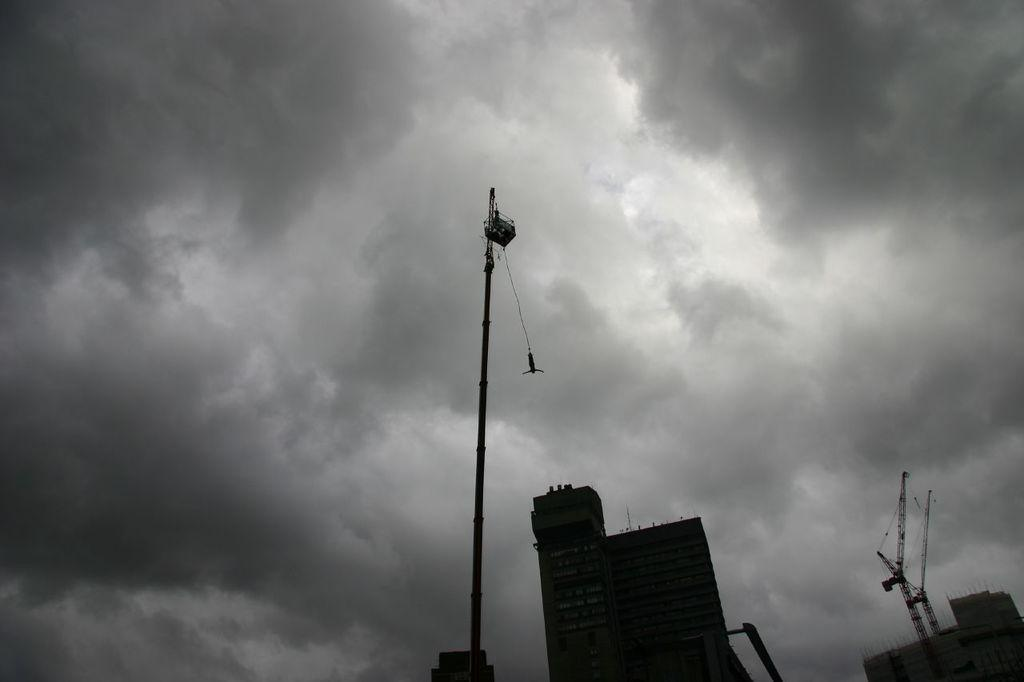What type of structures can be seen in the image? There are buildings in the image. What equipment is present in the image? There are cranes in the image. Can you describe a specific object in the image? There is a pole in the image. What else can be seen in the image besides the buildings and cranes? There are some unspecified objects in the image. What is visible in the background of the image? The sky is visible in the background of the image, and there are clouds in the sky. What type of store can be seen in the image? There is no store present in the image. What part of the human body is visible in the image? There are no human body parts visible in the image. 